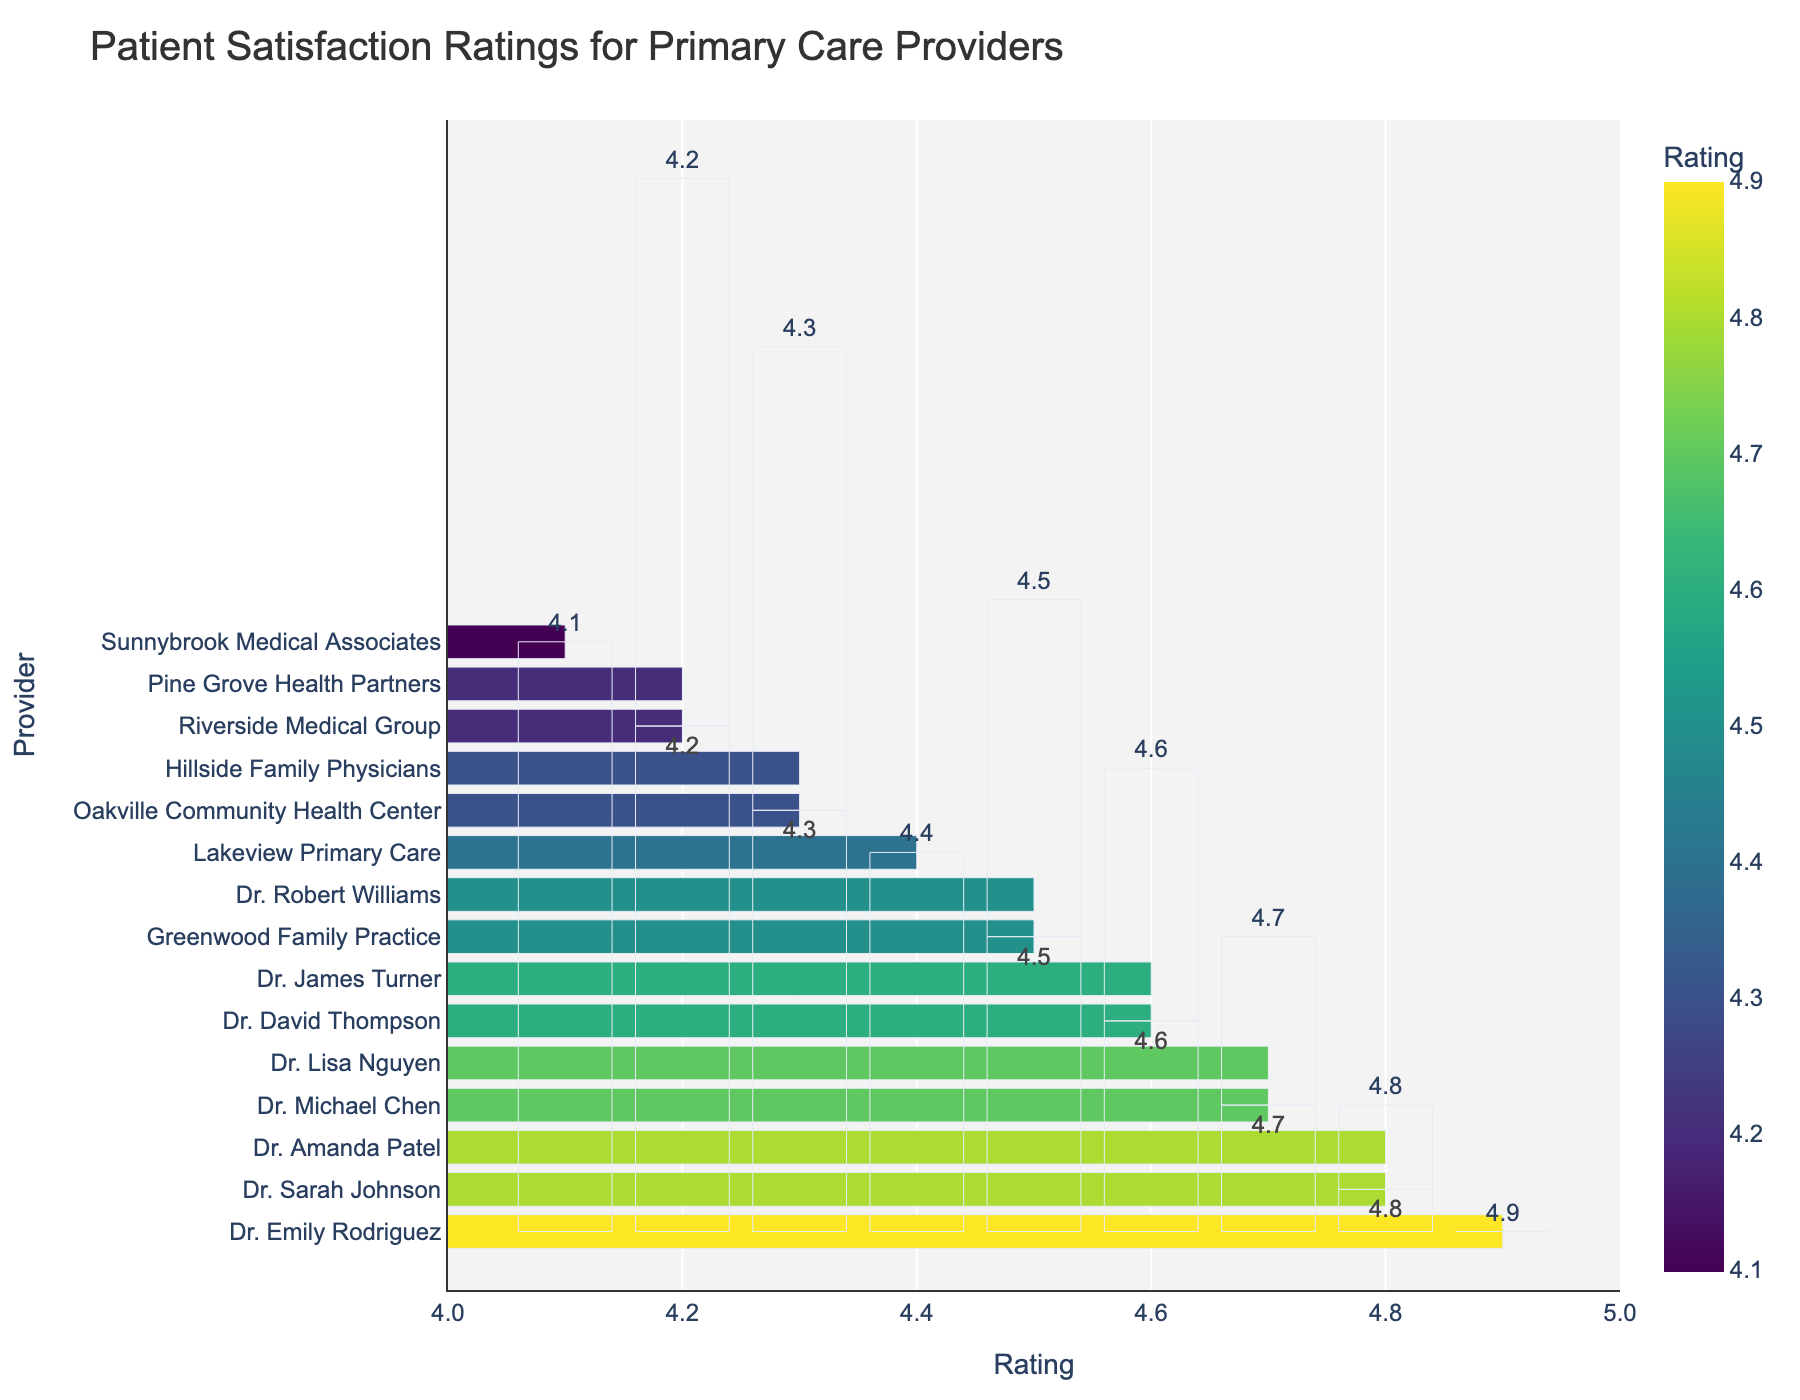What's the highest patient satisfaction rating among the providers? The bar chart shows various providers with their satisfaction ratings. The tallest bar has a rating of 4.9, which corresponds to Dr. Emily Rodriguez.
Answer: 4.9 Which provider has the lowest patient satisfaction rating? To identify the provider with the lowest satisfaction rating, find the shortest bar on the chart. Sunnybrook Medical Associates has the shortest bar with a satisfaction rating of 4.1.
Answer: Sunnybrook Medical Associates How many providers have a satisfaction rating of 4.8? To determine this, count the number of bars labeled with a satisfaction rating of 4.8. There are two providers: Dr. Sarah Johnson and Dr. Amanda Patel.
Answer: 2 What's the difference in satisfaction ratings between the top-rated and the lowest-rated providers? The top-rated provider is Dr. Emily Rodriguez with a 4.9 rating, and the lowest-rated provider is Sunnybrook Medical Associates with a 4.1 rating. The difference is 4.9 - 4.1 = 0.8.
Answer: 0.8 What is the average satisfaction rating of all providers displayed in the chart? Add up all the satisfaction ratings and divide by the number of providers. The sum of ratings is 4.8 + 4.5 + 4.7 + 4.2 + 4.9 + 4.3 + 4.6 + 4.4 + 4.8 + 4.1 + 4.5 + 4.3 + 4.7 + 4.2 + 4.6 = 67.6. There are 15 providers: 67.6 / 15 = 4.51.
Answer: 4.51 Which providers have satisfaction ratings that are above the average rating? The average rating is 4.51. Identify bars with ratings higher than 4.51. The providers are Dr. Sarah Johnson, Dr. Michael Chen, Dr. Emily Rodriguez, Dr. David Thompson, Dr. Amanda Patel, and Dr. Lisa Nguyen.
Answer: Dr. Sarah Johnson, Dr. Michael Chen, Dr. Emily Rodriguez, Dr. David Thompson, Dr. Amanda Patel, Dr. Lisa Nguyen Which two providers have equal satisfaction ratings of 4.5? Examine the chart to find providers with the same rating of 4.5. The providers are Greenwood Family Practice and Dr. Robert Williams.
Answer: Greenwood Family Practice, Dr. Robert Williams How many providers have satisfaction ratings between 4.3 and 4.6, inclusive? Count the number of bars with ratings in this range. Providers with ratings 4.3, 4.4, 4.5, and 4.6 fall into this category. Providers are Riverside Medical Group, Oakville Community Health Center, Hillside Family Physicians, Lakeview Primary Care, Dr. David Thompson, Pine Grove Health Partners, and Dr. James Turner, totaling 7 providers.
Answer: 7 Which three providers are immediately below Dr. Emily Rodriguez in terms of ratings? Dr. Emily Rodriguez has the highest rating of 4.9. The next three providers with the highest ratings are Dr. Sarah Johnson (4.8), Dr. Amanda Patel (4.8), and Dr. Michael Chen (4.7).
Answer: Dr. Sarah Johnson, Dr. Amanda Patel, Dr. Michael Chen 